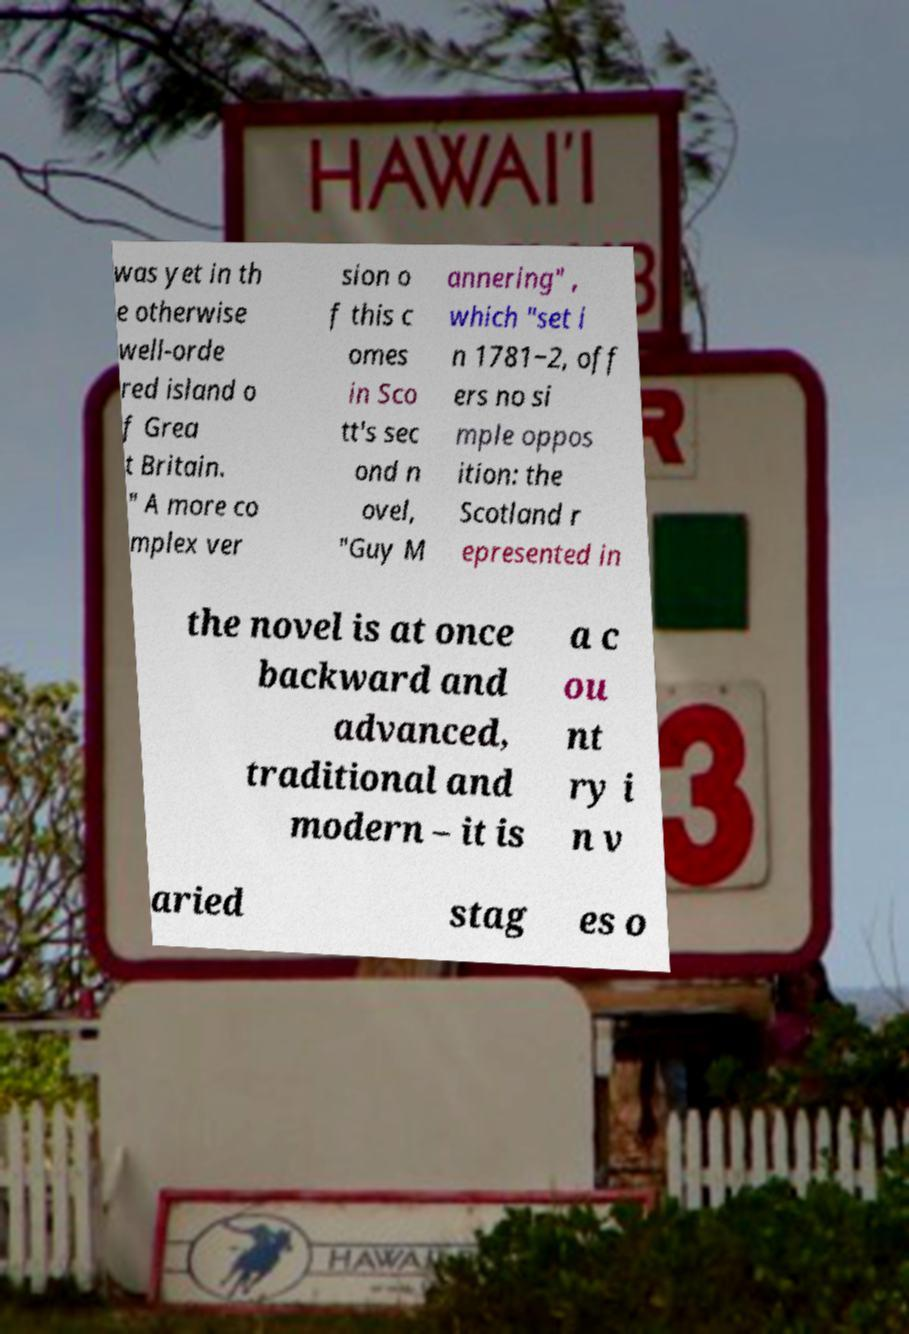Please identify and transcribe the text found in this image. was yet in th e otherwise well-orde red island o f Grea t Britain. " A more co mplex ver sion o f this c omes in Sco tt's sec ond n ovel, "Guy M annering" , which "set i n 1781‒2, off ers no si mple oppos ition: the Scotland r epresented in the novel is at once backward and advanced, traditional and modern – it is a c ou nt ry i n v aried stag es o 